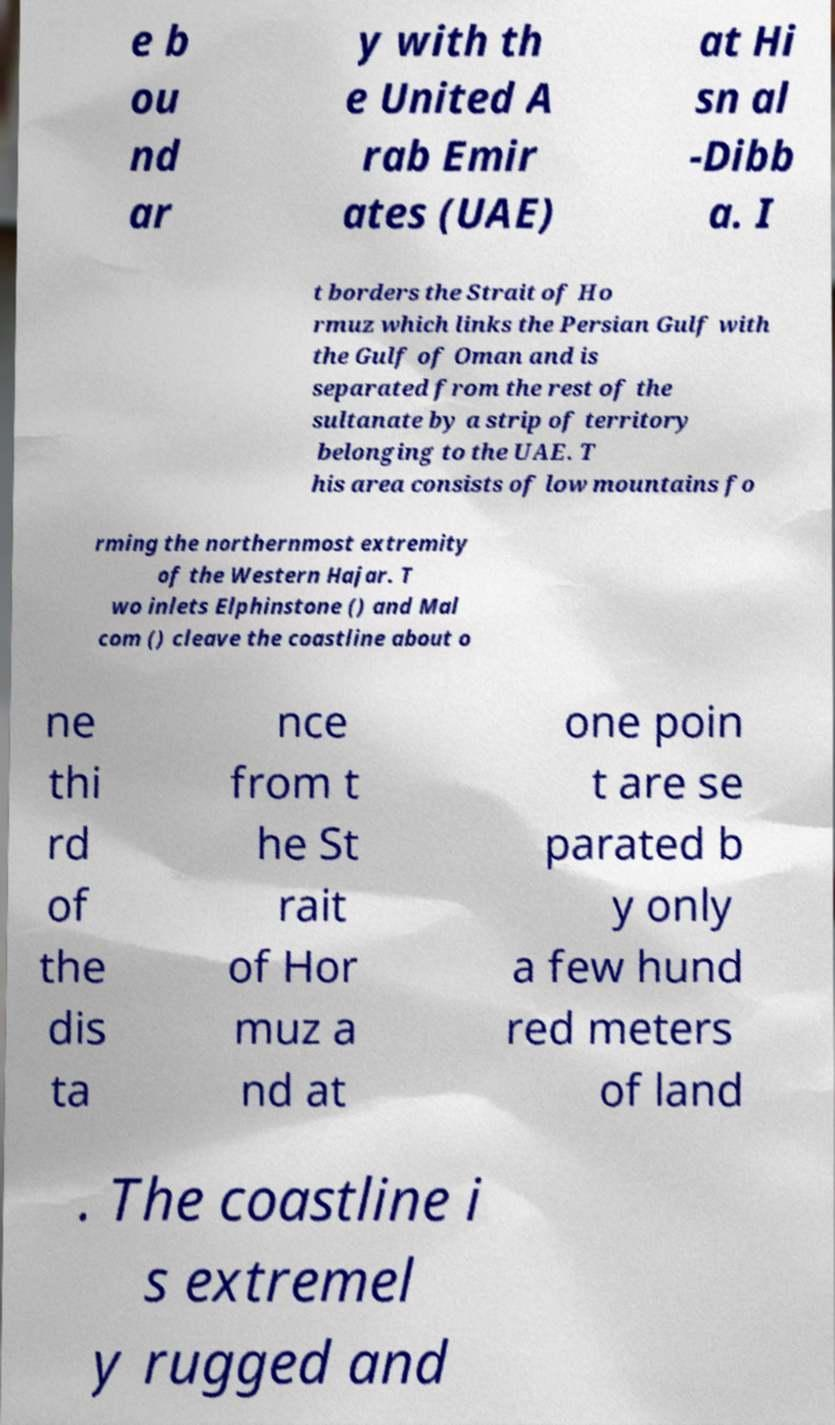There's text embedded in this image that I need extracted. Can you transcribe it verbatim? e b ou nd ar y with th e United A rab Emir ates (UAE) at Hi sn al -Dibb a. I t borders the Strait of Ho rmuz which links the Persian Gulf with the Gulf of Oman and is separated from the rest of the sultanate by a strip of territory belonging to the UAE. T his area consists of low mountains fo rming the northernmost extremity of the Western Hajar. T wo inlets Elphinstone () and Mal com () cleave the coastline about o ne thi rd of the dis ta nce from t he St rait of Hor muz a nd at one poin t are se parated b y only a few hund red meters of land . The coastline i s extremel y rugged and 